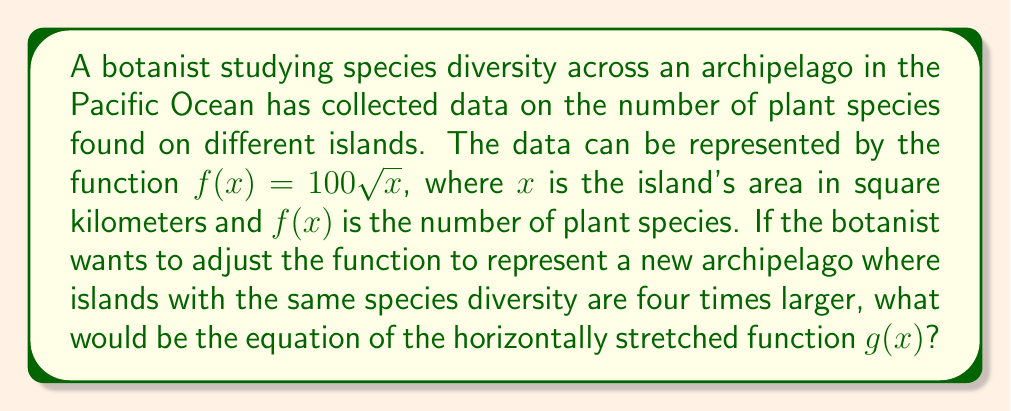Could you help me with this problem? To solve this problem, we need to apply a horizontal stretch to the original function $f(x)$. The process is as follows:

1) The original function is $f(x) = 100\sqrt{x}$.

2) We're told that islands with the same species diversity are four times larger in the new archipelago. This means we need to apply a horizontal stretch by a factor of 4.

3) For a horizontal stretch by a factor of $k$, we replace $x$ with $\frac{x}{k}$ in the original function. In this case, $k = 4$.

4) Therefore, our new function $g(x)$ will be:

   $g(x) = f(\frac{x}{4})$

5) Substituting the original function:

   $g(x) = 100\sqrt{\frac{x}{4}}$

6) We can simplify this further:

   $g(x) = 100\sqrt{\frac{x}{4}} = 100 \cdot \frac{\sqrt{x}}{\sqrt{4}} = 50\sqrt{x}$

Thus, the equation of the horizontally stretched function is $g(x) = 50\sqrt{x}$.

This new function represents the species diversity in the new archipelago, where an island needs to be four times larger to support the same number of species as in the original archipelago.
Answer: $g(x) = 50\sqrt{x}$ 